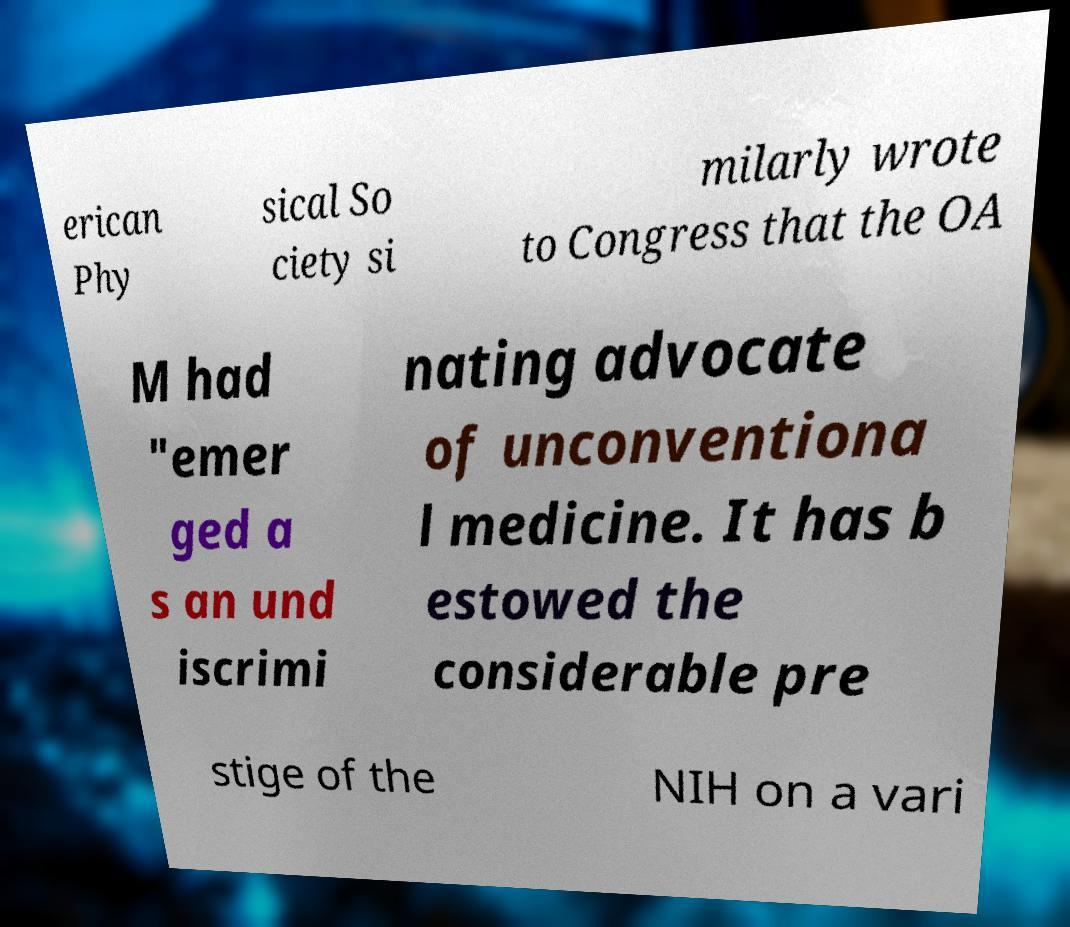What messages or text are displayed in this image? I need them in a readable, typed format. erican Phy sical So ciety si milarly wrote to Congress that the OA M had "emer ged a s an und iscrimi nating advocate of unconventiona l medicine. It has b estowed the considerable pre stige of the NIH on a vari 